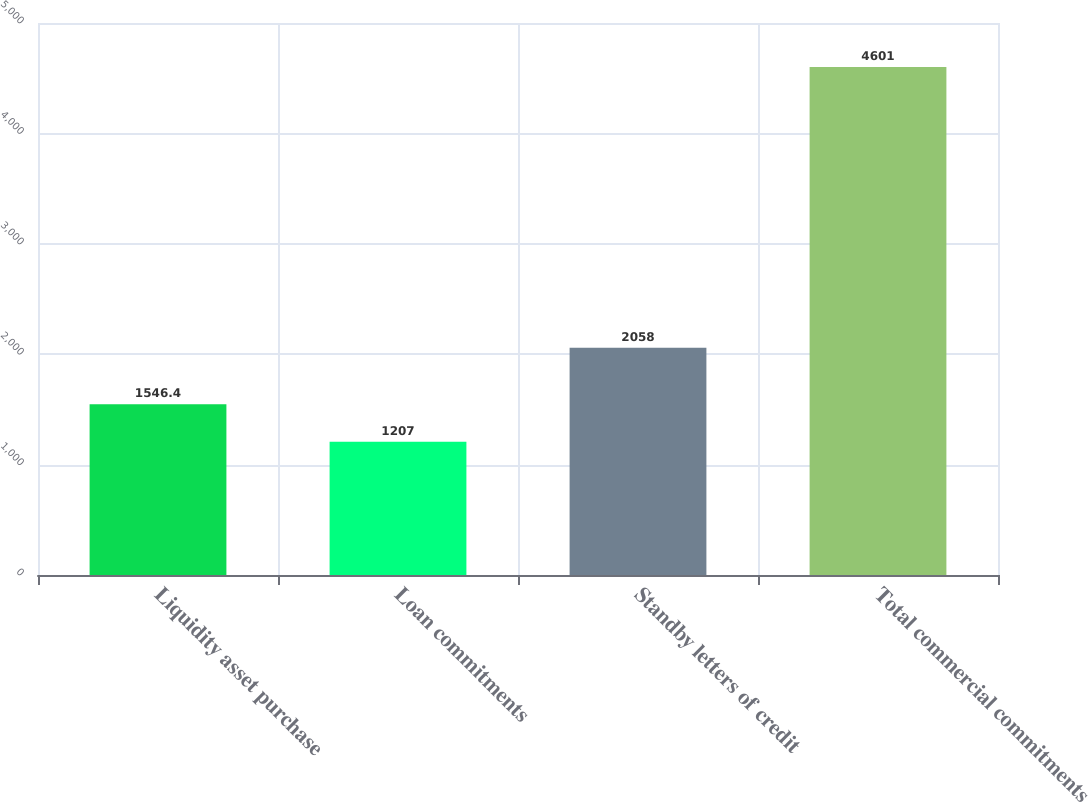Convert chart to OTSL. <chart><loc_0><loc_0><loc_500><loc_500><bar_chart><fcel>Liquidity asset purchase<fcel>Loan commitments<fcel>Standby letters of credit<fcel>Total commercial commitments<nl><fcel>1546.4<fcel>1207<fcel>2058<fcel>4601<nl></chart> 